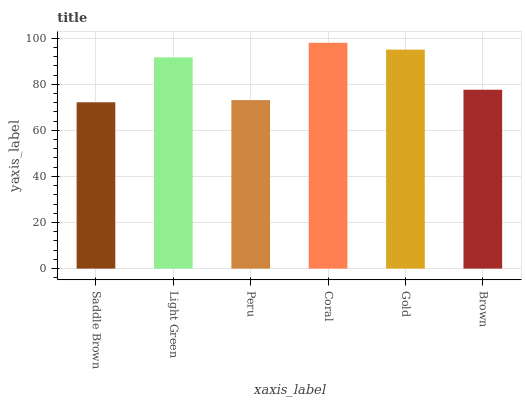Is Saddle Brown the minimum?
Answer yes or no. Yes. Is Coral the maximum?
Answer yes or no. Yes. Is Light Green the minimum?
Answer yes or no. No. Is Light Green the maximum?
Answer yes or no. No. Is Light Green greater than Saddle Brown?
Answer yes or no. Yes. Is Saddle Brown less than Light Green?
Answer yes or no. Yes. Is Saddle Brown greater than Light Green?
Answer yes or no. No. Is Light Green less than Saddle Brown?
Answer yes or no. No. Is Light Green the high median?
Answer yes or no. Yes. Is Brown the low median?
Answer yes or no. Yes. Is Peru the high median?
Answer yes or no. No. Is Gold the low median?
Answer yes or no. No. 